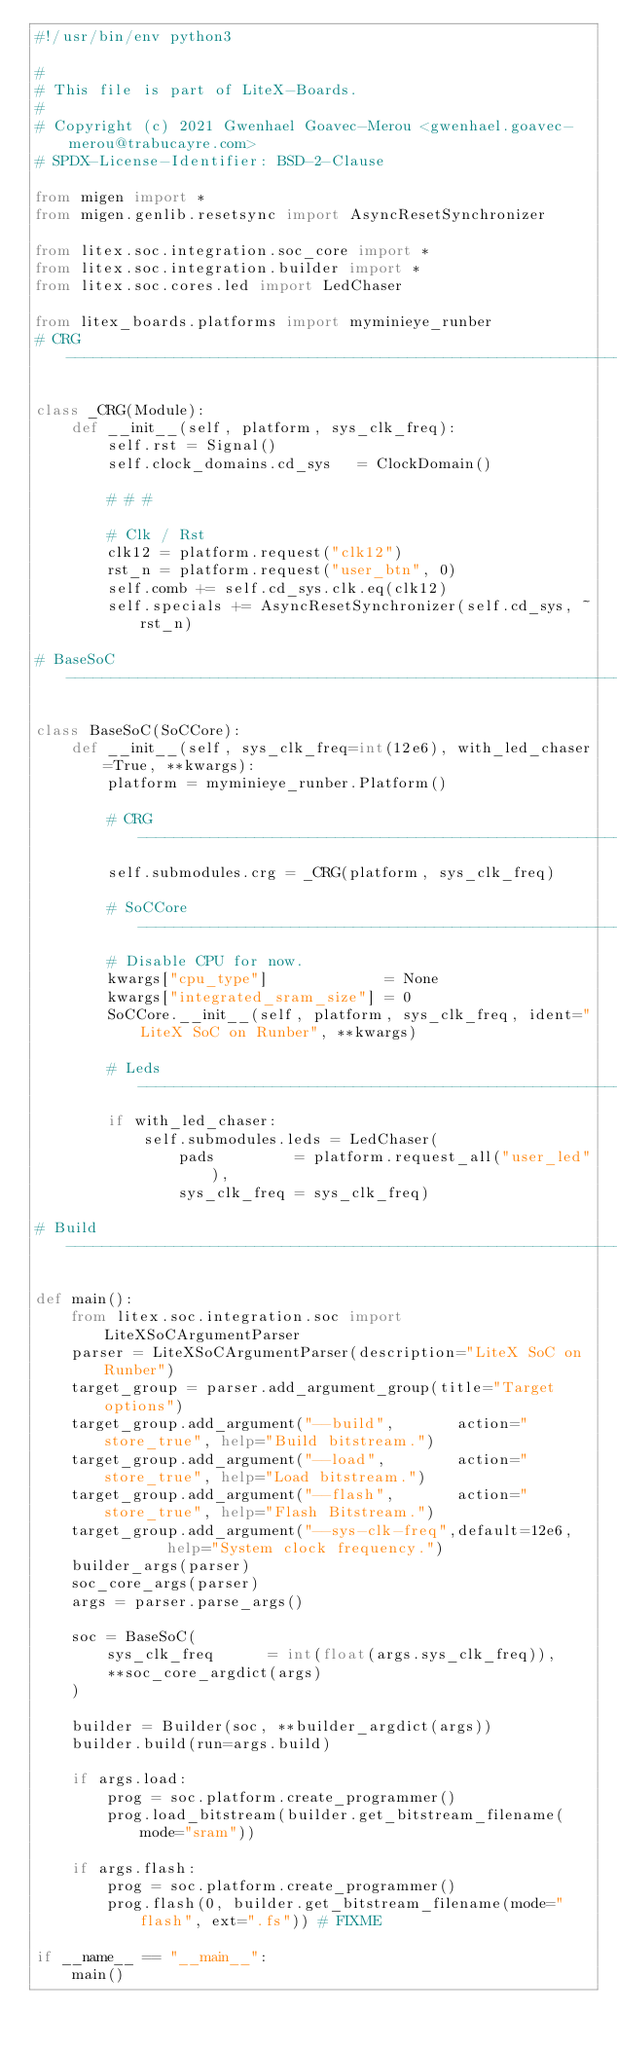<code> <loc_0><loc_0><loc_500><loc_500><_Python_>#!/usr/bin/env python3

#
# This file is part of LiteX-Boards.
#
# Copyright (c) 2021 Gwenhael Goavec-Merou <gwenhael.goavec-merou@trabucayre.com>
# SPDX-License-Identifier: BSD-2-Clause

from migen import *
from migen.genlib.resetsync import AsyncResetSynchronizer

from litex.soc.integration.soc_core import *
from litex.soc.integration.builder import *
from litex.soc.cores.led import LedChaser

from litex_boards.platforms import myminieye_runber
# CRG ----------------------------------------------------------------------------------------------

class _CRG(Module):
    def __init__(self, platform, sys_clk_freq):
        self.rst = Signal()
        self.clock_domains.cd_sys   = ClockDomain()

        # # #

        # Clk / Rst
        clk12 = platform.request("clk12")
        rst_n = platform.request("user_btn", 0)
        self.comb += self.cd_sys.clk.eq(clk12)
        self.specials += AsyncResetSynchronizer(self.cd_sys, ~rst_n)

# BaseSoC ------------------------------------------------------------------------------------------

class BaseSoC(SoCCore):
    def __init__(self, sys_clk_freq=int(12e6), with_led_chaser=True, **kwargs):
        platform = myminieye_runber.Platform()

        # CRG --------------------------------------------------------------------------------------
        self.submodules.crg = _CRG(platform, sys_clk_freq)

        # SoCCore ----------------------------------------------------------------------------------
        # Disable CPU for now.
        kwargs["cpu_type"]             = None
        kwargs["integrated_sram_size"] = 0
        SoCCore.__init__(self, platform, sys_clk_freq, ident="LiteX SoC on Runber", **kwargs)

        # Leds -------------------------------------------------------------------------------------
        if with_led_chaser:
            self.submodules.leds = LedChaser(
                pads         = platform.request_all("user_led"),
                sys_clk_freq = sys_clk_freq)

# Build --------------------------------------------------------------------------------------------

def main():
    from litex.soc.integration.soc import LiteXSoCArgumentParser
    parser = LiteXSoCArgumentParser(description="LiteX SoC on Runber")
    target_group = parser.add_argument_group(title="Target options")
    target_group.add_argument("--build",       action="store_true", help="Build bitstream.")
    target_group.add_argument("--load",        action="store_true", help="Load bitstream.")
    target_group.add_argument("--flash",       action="store_true", help="Flash Bitstream.")
    target_group.add_argument("--sys-clk-freq",default=12e6,        help="System clock frequency.")
    builder_args(parser)
    soc_core_args(parser)
    args = parser.parse_args()

    soc = BaseSoC(
        sys_clk_freq      = int(float(args.sys_clk_freq)),
        **soc_core_argdict(args)
    )

    builder = Builder(soc, **builder_argdict(args))
    builder.build(run=args.build)

    if args.load:
        prog = soc.platform.create_programmer()
        prog.load_bitstream(builder.get_bitstream_filename(mode="sram"))

    if args.flash:
        prog = soc.platform.create_programmer()
        prog.flash(0, builder.get_bitstream_filename(mode="flash", ext=".fs")) # FIXME

if __name__ == "__main__":
    main()
</code> 